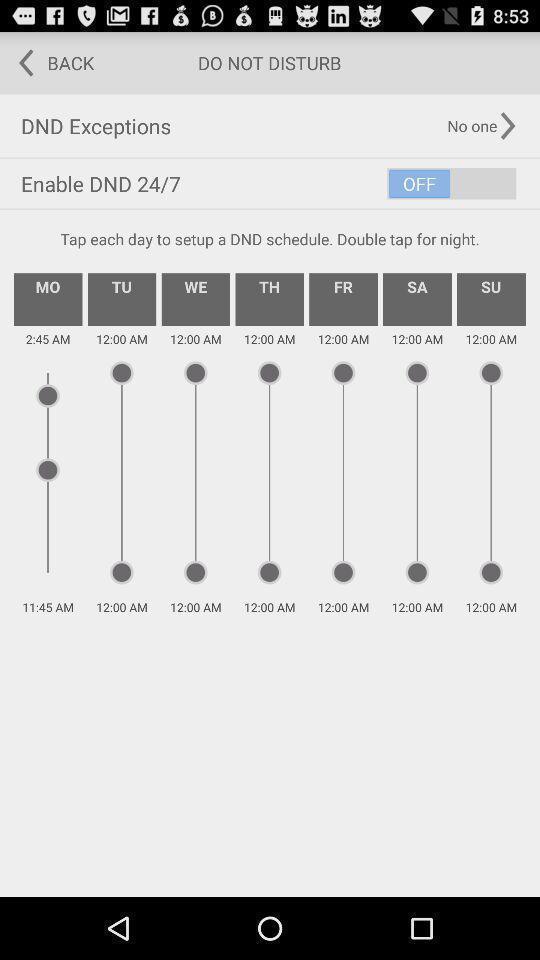Describe this image in words. Screen displaying do not disturb page. 